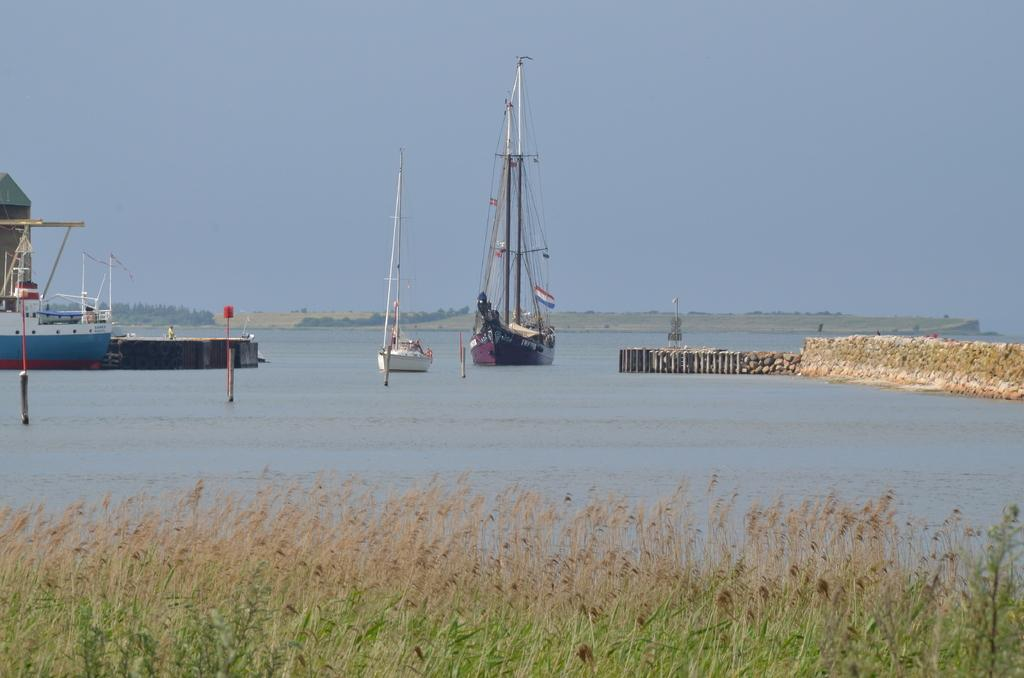What is on the water in the image? There are boats on the water in the image. What else can be seen in the image besides the boats? There are plants and objects visible in the image. What is in the background of the image? There are trees and the sky visible in the background of the image. Where is the library located in the image? There is no library present in the image. What theory can be observed in action in the image? There is no theory mentioned or depicted in the image. 